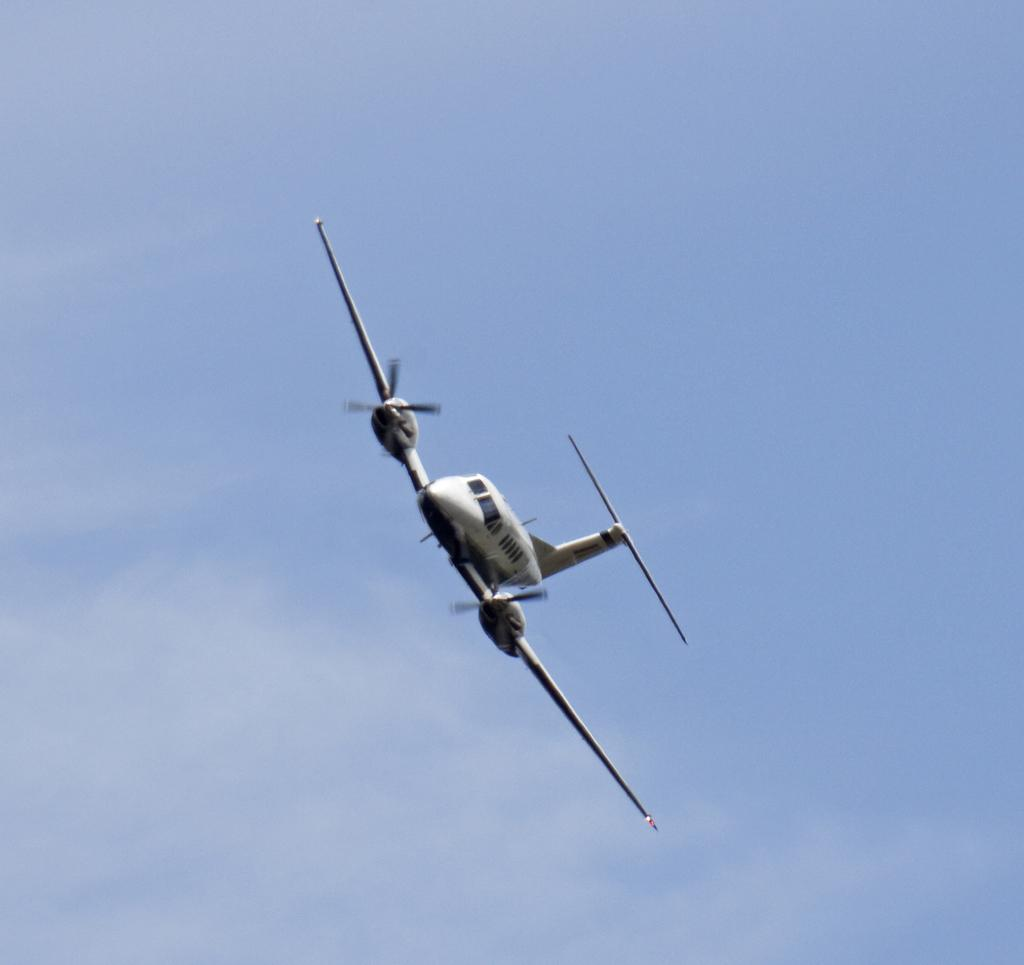What is the main subject of the image? The main subject of the image is a plane. Can you describe the plane's location in the image? The plane is in the air. What else can be seen in the sky in the image? There are clouds in the sky. How many snakes are slithering on the plane's wing in the image? There are no snakes present in the image; the plane is in the air with clouds in the sky. 